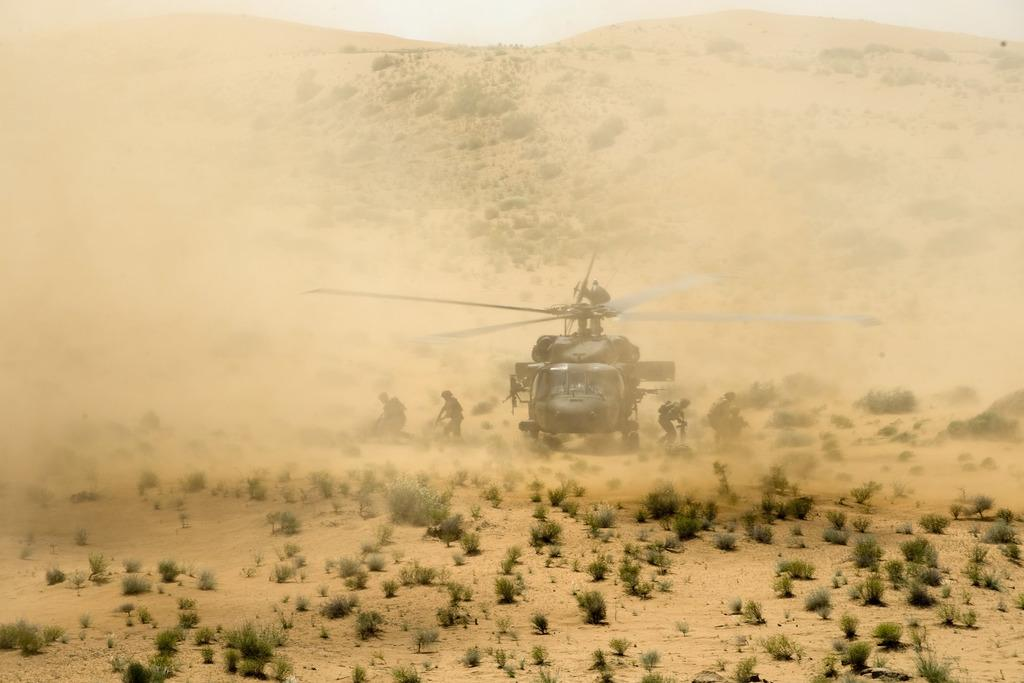What type of vehicle is on the land in the image? There is a helicopter on the land in the image. Are there any people present on the land in the image? Yes, there are people on the land in the image. What can be seen growing in the image? Plants are visible in the image. What is the condition of the ground in the image? Dust is present in the image. What is visible in the background of the image? There is sky visible in the background of the image. What is the opinion of the kitty about the helicopter in the image? There is no kitty present in the image, so it is not possible to determine its opinion about the helicopter. 